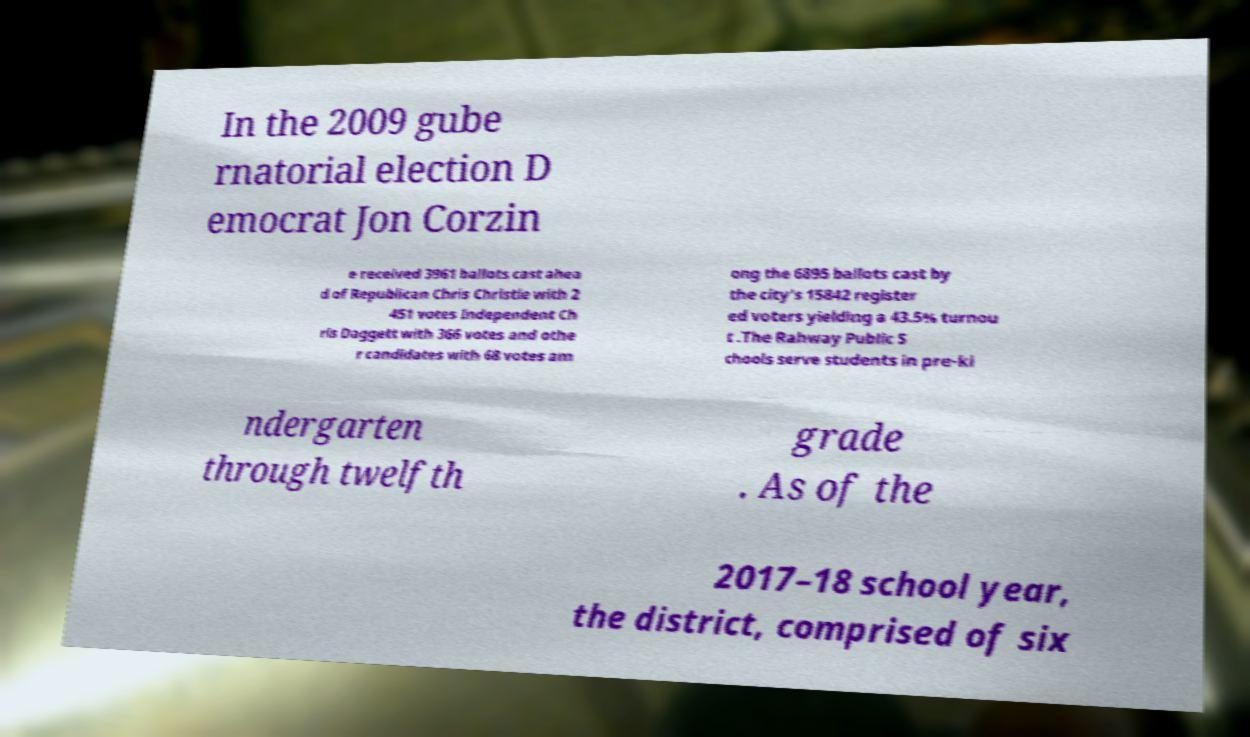I need the written content from this picture converted into text. Can you do that? In the 2009 gube rnatorial election D emocrat Jon Corzin e received 3961 ballots cast ahea d of Republican Chris Christie with 2 451 votes Independent Ch ris Daggett with 366 votes and othe r candidates with 68 votes am ong the 6895 ballots cast by the city's 15842 register ed voters yielding a 43.5% turnou t .The Rahway Public S chools serve students in pre-ki ndergarten through twelfth grade . As of the 2017–18 school year, the district, comprised of six 